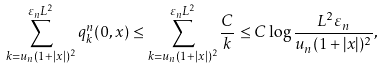<formula> <loc_0><loc_0><loc_500><loc_500>\sum _ { k = u _ { n } ( 1 + | x | ) ^ { 2 } } ^ { \varepsilon _ { n } L ^ { 2 } } q ^ { n } _ { k } ( 0 , x ) \leq \sum _ { k = u _ { n } ( 1 + | x | ) ^ { 2 } } ^ { \varepsilon _ { n } L ^ { 2 } } \frac { C } { k } \leq C \log \frac { L ^ { 2 } \varepsilon _ { n } } { u _ { n } ( 1 + | x | ) ^ { 2 } } ,</formula> 